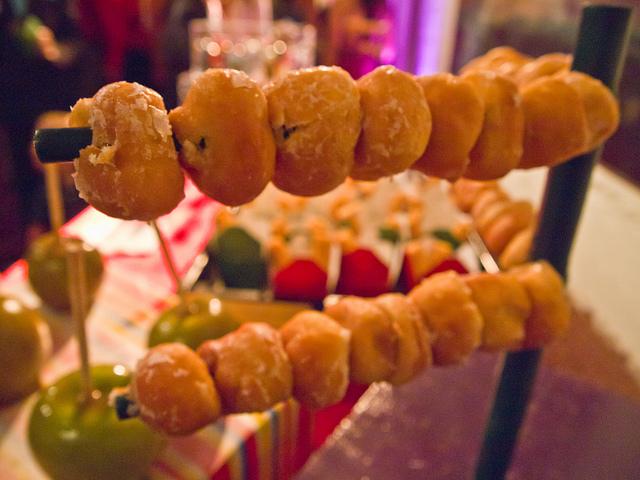What green object is on a wood stick?
Short answer required. Apple. What kind of food is that?
Short answer required. Donut holes. Where are the apples resting?
Short answer required. Table. 